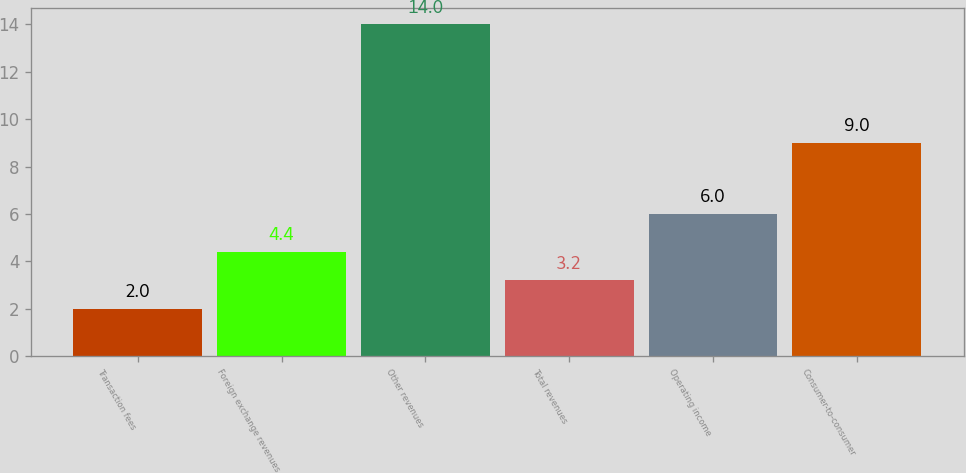<chart> <loc_0><loc_0><loc_500><loc_500><bar_chart><fcel>Transaction fees<fcel>Foreign exchange revenues<fcel>Other revenues<fcel>Total revenues<fcel>Operating income<fcel>Consumer-to-consumer<nl><fcel>2<fcel>4.4<fcel>14<fcel>3.2<fcel>6<fcel>9<nl></chart> 